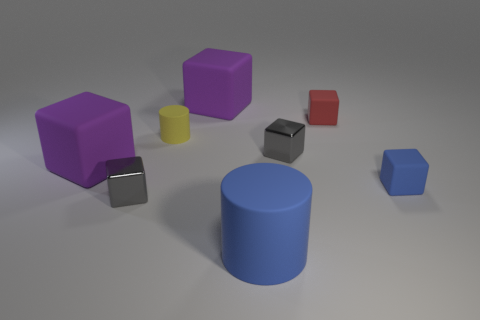What material do the objects in the image look like they are made of? The objects in the image appear to have a matte surface indicating they might be made of a material like rubber.  Can you compare the shades of colors of the different objects? Certainly, the image displays a variety of shades. The two cubes on the left have a vibrant purple, and the cylinder has a similar hue but in a darker tone. The small block in the center appears to be a muted gray, contrasting against the more vivid red and blue blocks. 